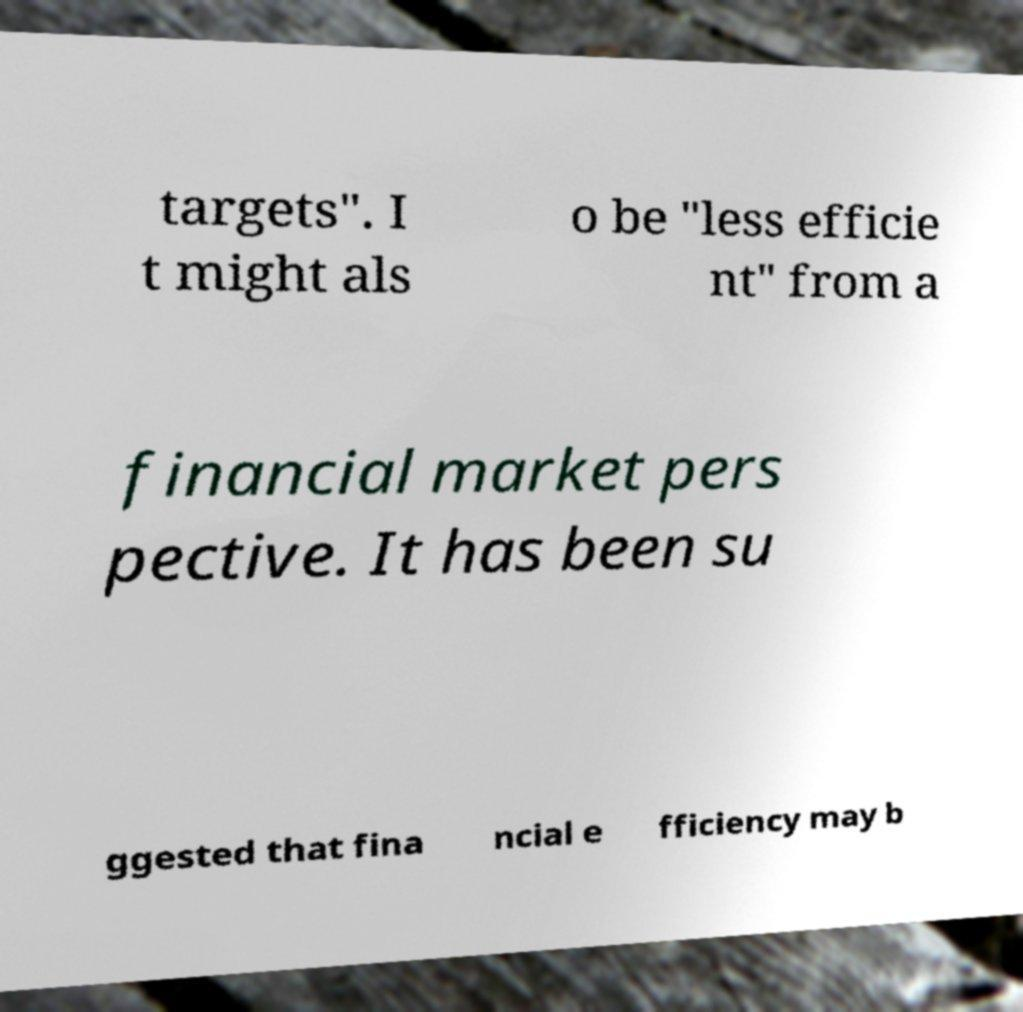For documentation purposes, I need the text within this image transcribed. Could you provide that? targets". I t might als o be "less efficie nt" from a financial market pers pective. It has been su ggested that fina ncial e fficiency may b 